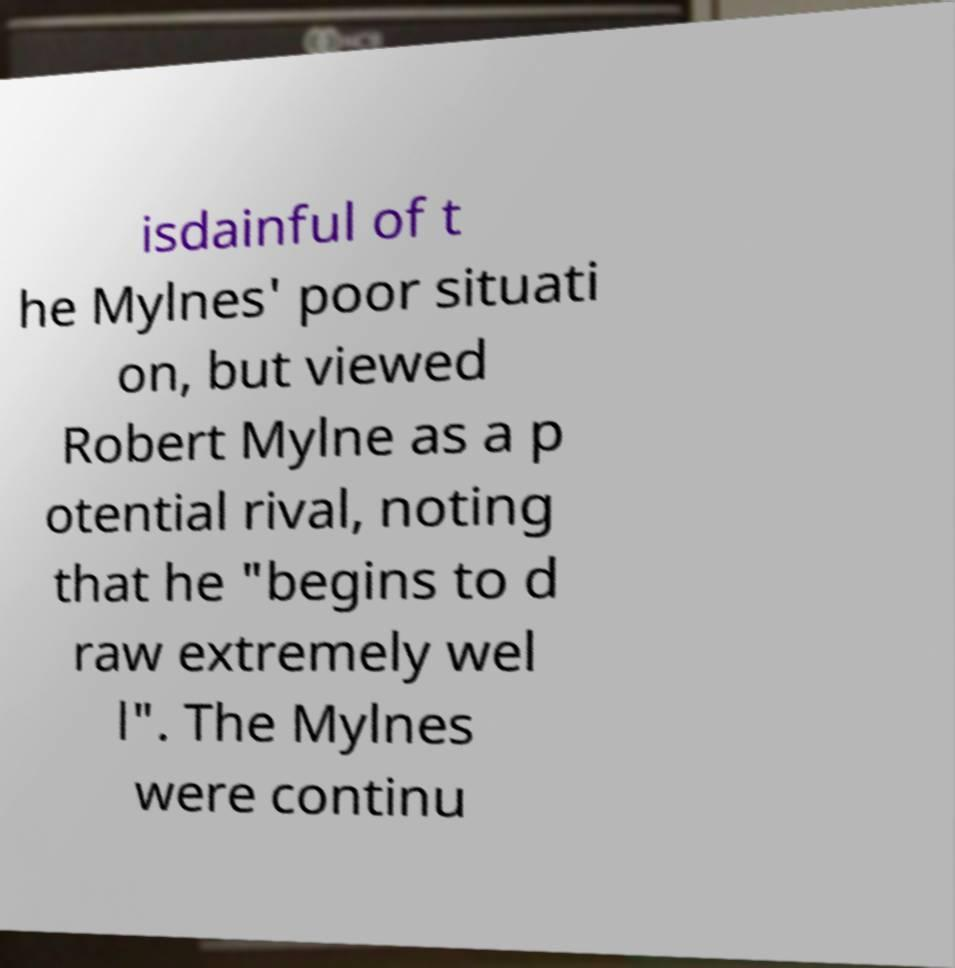For documentation purposes, I need the text within this image transcribed. Could you provide that? isdainful of t he Mylnes' poor situati on, but viewed Robert Mylne as a p otential rival, noting that he "begins to d raw extremely wel l". The Mylnes were continu 